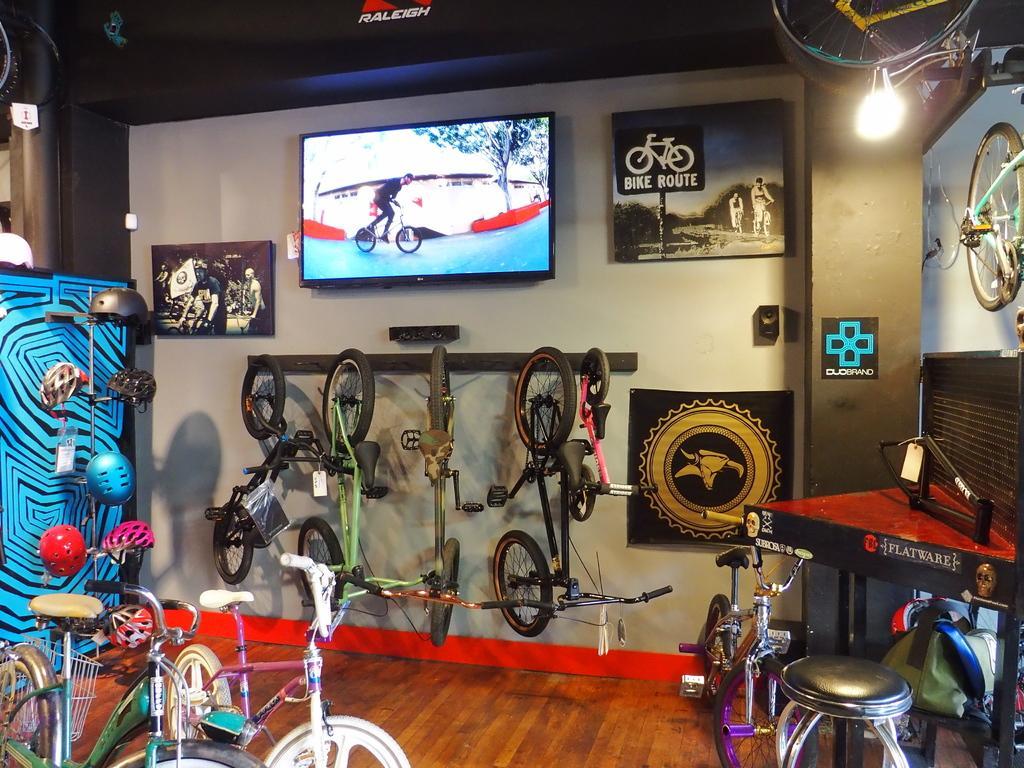Could you give a brief overview of what you see in this image? In this image I can see the bicycles. On the right side, I can see a stool. On the left side I can see the helmets. In the background, I can see the boards. I can see also see something projected on the screen. At the top I can see the light. 